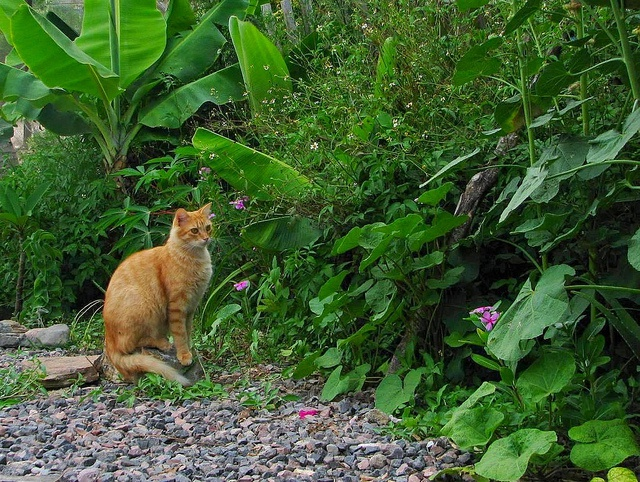Describe the objects in this image and their specific colors. I can see a cat in green, olive, and tan tones in this image. 